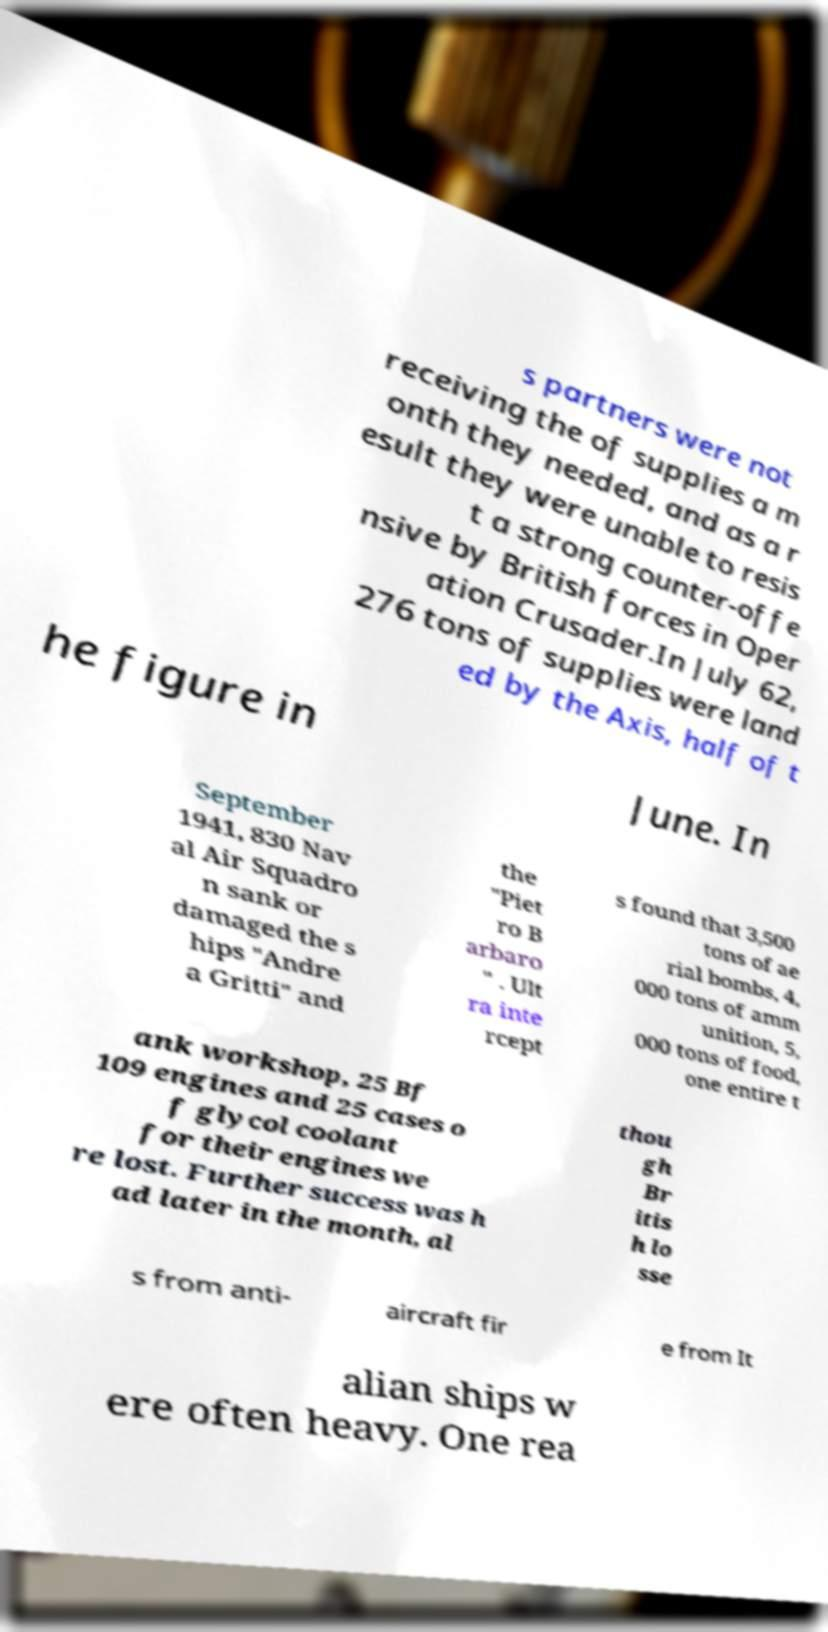Can you read and provide the text displayed in the image?This photo seems to have some interesting text. Can you extract and type it out for me? s partners were not receiving the of supplies a m onth they needed, and as a r esult they were unable to resis t a strong counter-offe nsive by British forces in Oper ation Crusader.In July 62, 276 tons of supplies were land ed by the Axis, half of t he figure in June. In September 1941, 830 Nav al Air Squadro n sank or damaged the s hips "Andre a Gritti" and the "Piet ro B arbaro " . Ult ra inte rcept s found that 3,500 tons of ae rial bombs, 4, 000 tons of amm unition, 5, 000 tons of food, one entire t ank workshop, 25 Bf 109 engines and 25 cases o f glycol coolant for their engines we re lost. Further success was h ad later in the month, al thou gh Br itis h lo sse s from anti- aircraft fir e from It alian ships w ere often heavy. One rea 